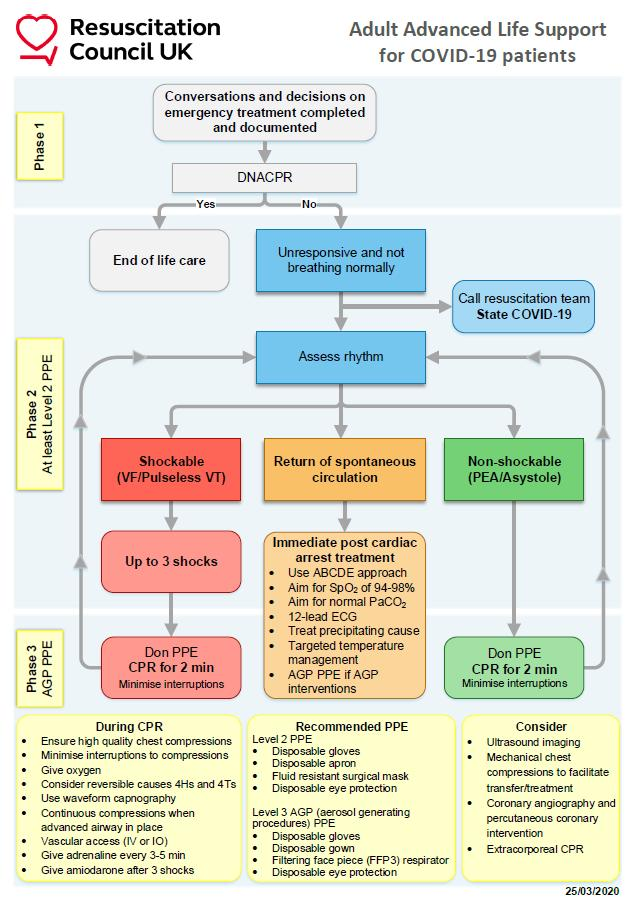List a handful of essential elements in this visual. When a COVID-19 patient's DNACPR status is marked as "Yes," it indicates that the patient has chosen to forego life-sustaining treatment and focus on end-of-life care. When a COVID-19 patient is unresponsive and not breathing normally, the following procedures must be carried out: assess the patient's rhythm, and immediately call for a resuscitation team while stating the patient's COVID-19 status. In the event that a COVID-19 patient's DNACPR (Do Not Attempt Cardiopulmonary Resuscitation) order is marked as "No," and the patient is unresponsive and not breathing normally, medical personnel will take appropriate action to provide life-sustaining measures, in accordance with the patient's advanced care directive. 